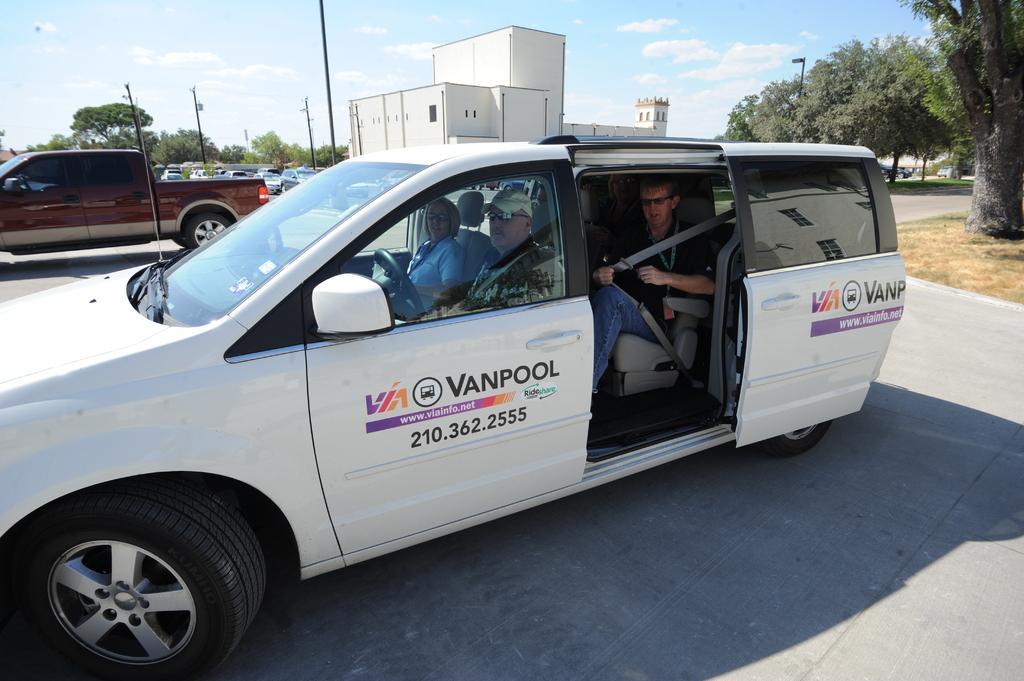How would you summarize this image in a sentence or two? This is a car which is parked on a parking space. In front of a car we can see a man and a woman and in the back a man and he is trying to put a seat belt. In the background we can see a house, a jeep, a tree and electric poles. 